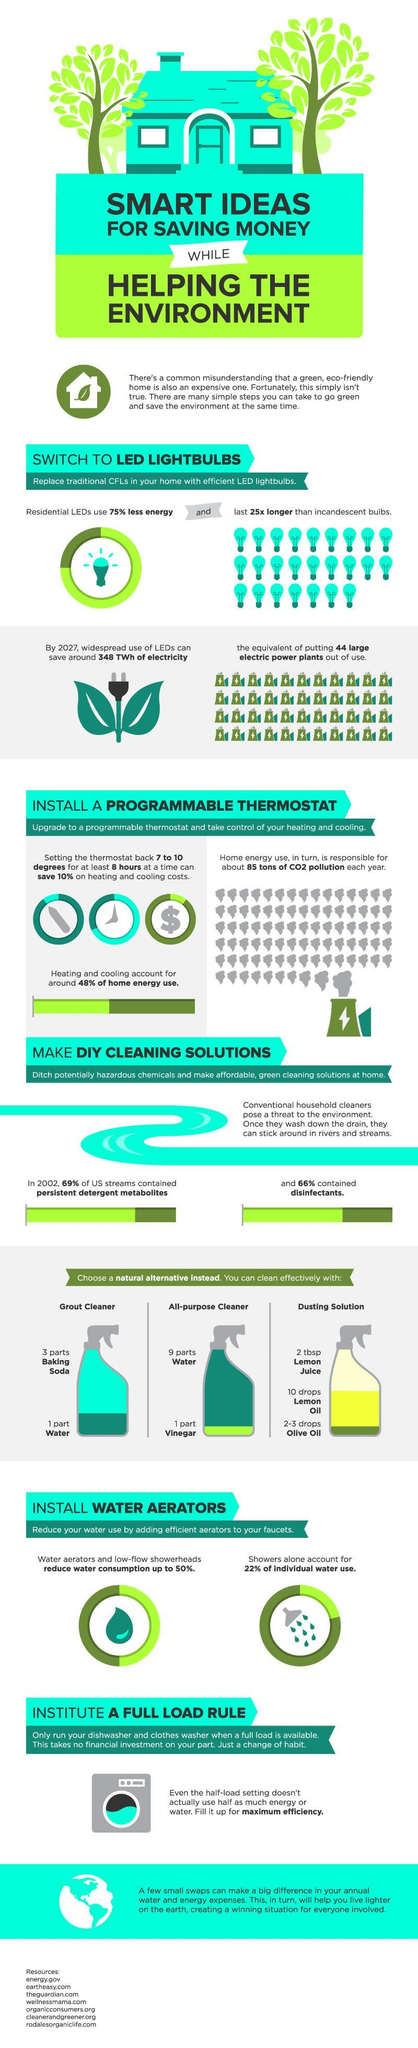What is the common ingredient in an all purpose cleaner and grout cleaner?
Answer the question with a short phrase. Water 